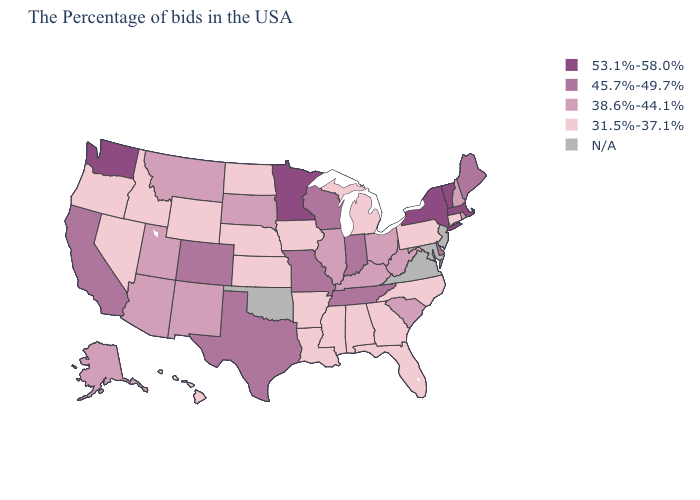Does Kansas have the lowest value in the USA?
Short answer required. Yes. Does the first symbol in the legend represent the smallest category?
Be succinct. No. What is the value of Oregon?
Concise answer only. 31.5%-37.1%. Among the states that border California , which have the highest value?
Answer briefly. Arizona. What is the lowest value in the USA?
Short answer required. 31.5%-37.1%. What is the value of West Virginia?
Concise answer only. 38.6%-44.1%. Name the states that have a value in the range 45.7%-49.7%?
Keep it brief. Maine, Delaware, Indiana, Tennessee, Wisconsin, Missouri, Texas, Colorado, California. What is the lowest value in the South?
Keep it brief. 31.5%-37.1%. How many symbols are there in the legend?
Give a very brief answer. 5. Which states hav the highest value in the South?
Quick response, please. Delaware, Tennessee, Texas. Does Minnesota have the highest value in the MidWest?
Short answer required. Yes. What is the lowest value in the USA?
Answer briefly. 31.5%-37.1%. What is the value of Tennessee?
Answer briefly. 45.7%-49.7%. What is the value of Michigan?
Quick response, please. 31.5%-37.1%. Is the legend a continuous bar?
Quick response, please. No. 